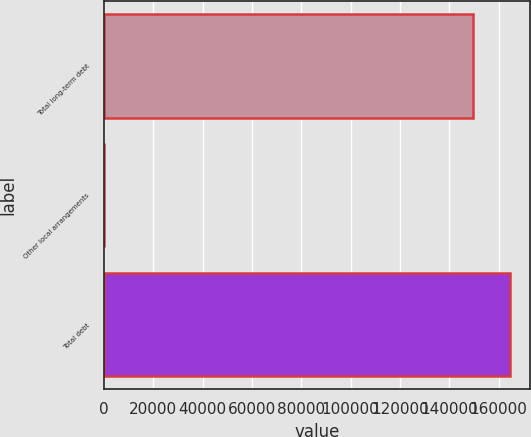Convert chart. <chart><loc_0><loc_0><loc_500><loc_500><bar_chart><fcel>Total long-term debt<fcel>Other local arrangements<fcel>Total debt<nl><fcel>149468<fcel>107<fcel>164415<nl></chart> 